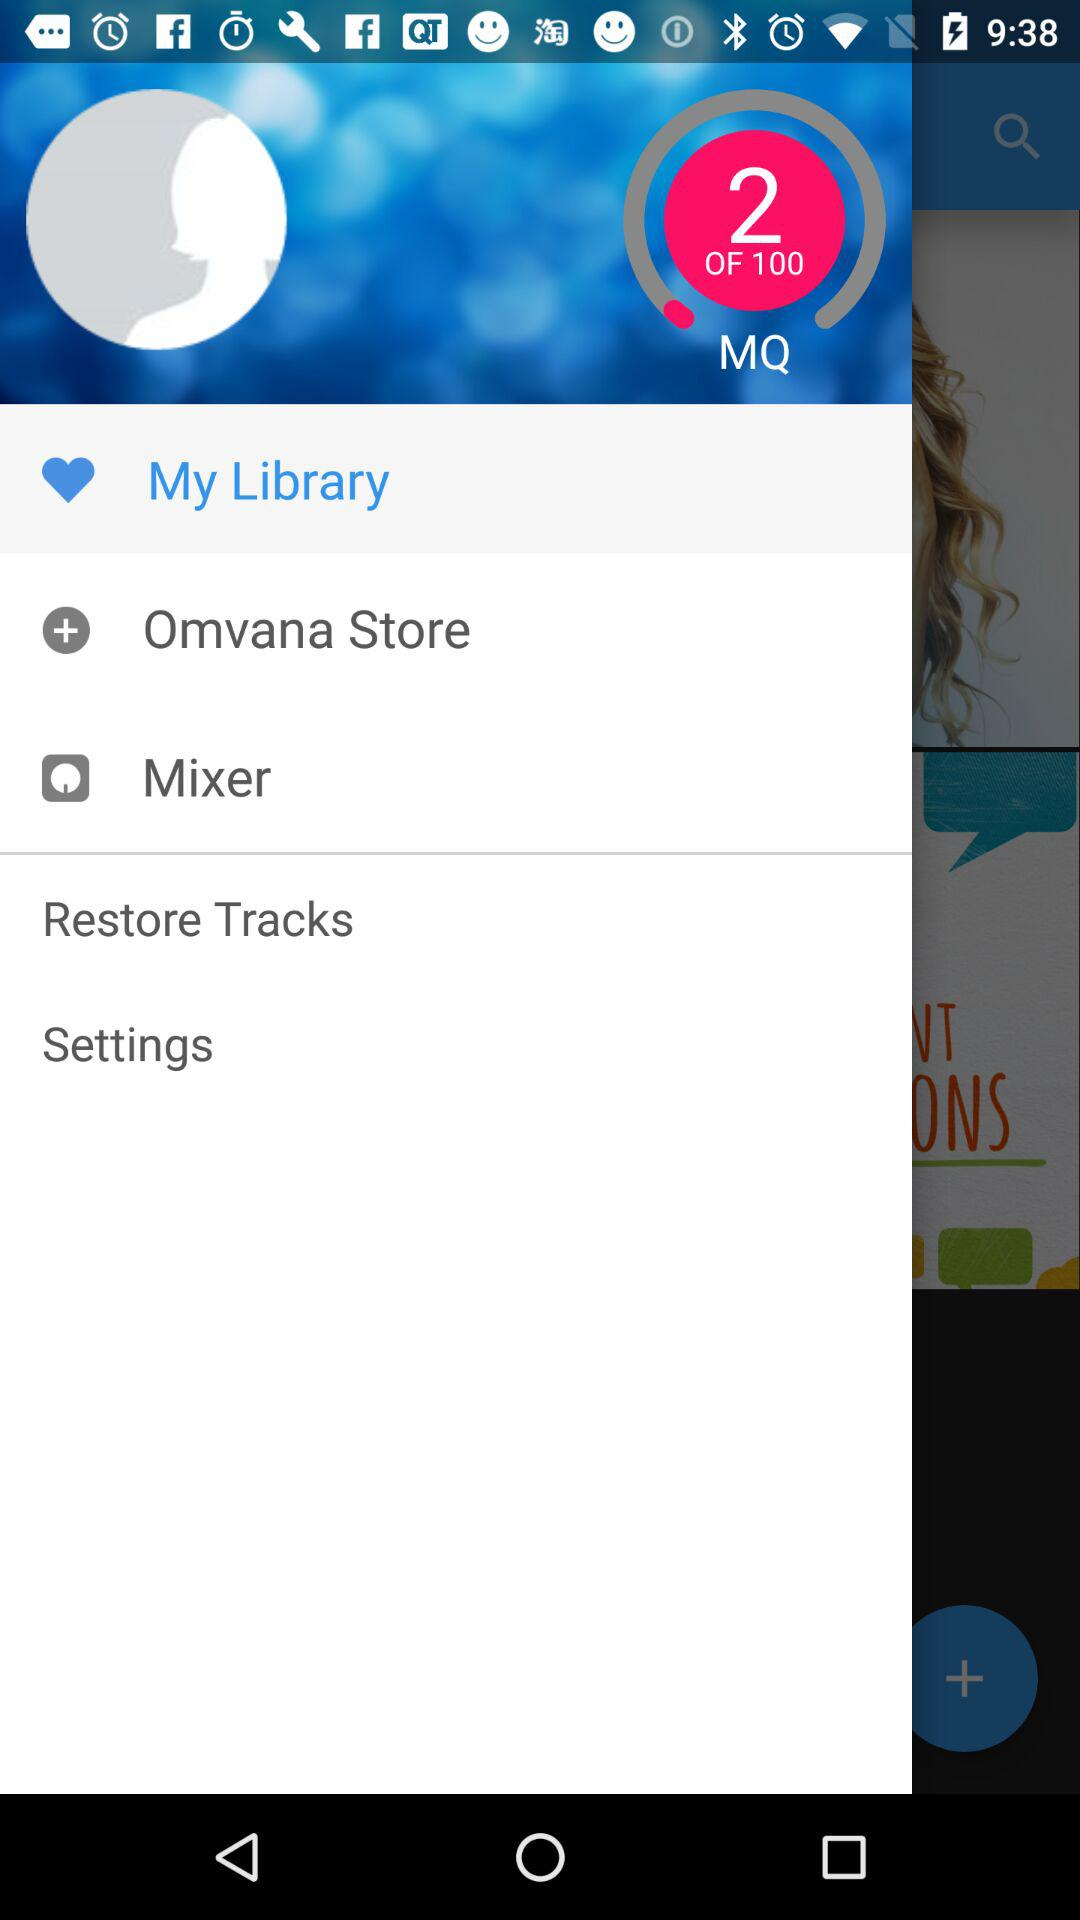What is the total count of MQ? The total count of MQ is 100. 